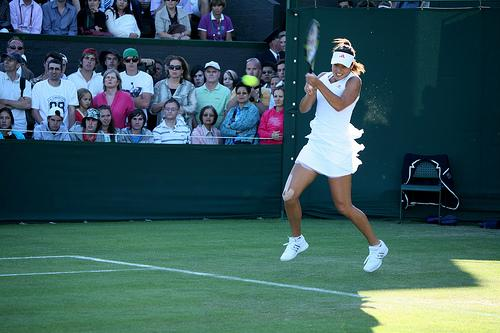In one sentence, describe the person in the image and their major activity. A woman dressed in white tennis attire, including a visor, is engaged in a tennis match while holding a racket. Give a brief portrayal of the individual and ongoing event in the image. A woman in white tennis gear and a visor is actively engaging in a tennis match while holding a racket. Express the essential idea of the photograph, focusing on the individual and their activity. A female tennis athlete equipped with a visor and tennis racket competes in a match, with a ball in motion. Using one sentence, reveal the core subject of the photograph and the action taking place. A female tennis player garbed in white attire and a visor is executing a move with a racket as a ball flies through the air. Present a brief overview of the image highlighting the person and their action. A tennis player dressed in white clothing and a visor is swinging a racket, while a tennis ball is in the air. Accurately summarize the primary scene in the photo. A woman in a white tennis ensemble, including a visor, is playing tennis with a racket in hand as a ball is in play. Explain the essential focus of the picture in a single sentence. A woman in a white tennis dress and visor is holding a tennis racket during a match. Mention the central figure in the photo and what is happening around them. A woman in a white tennis outfit and visor is playing tennis, with spectators sitting in the stands and a jacket hanging on a chair nearby. Describe the main character in the picture and their current activity. A tennis player wearing a white outfit and visor is holding a racket and participating in a match. Provide a concise summary of the primary action in the photo. A female tennis player is holding a racket and wearing a white tennis outfit with a visor. 